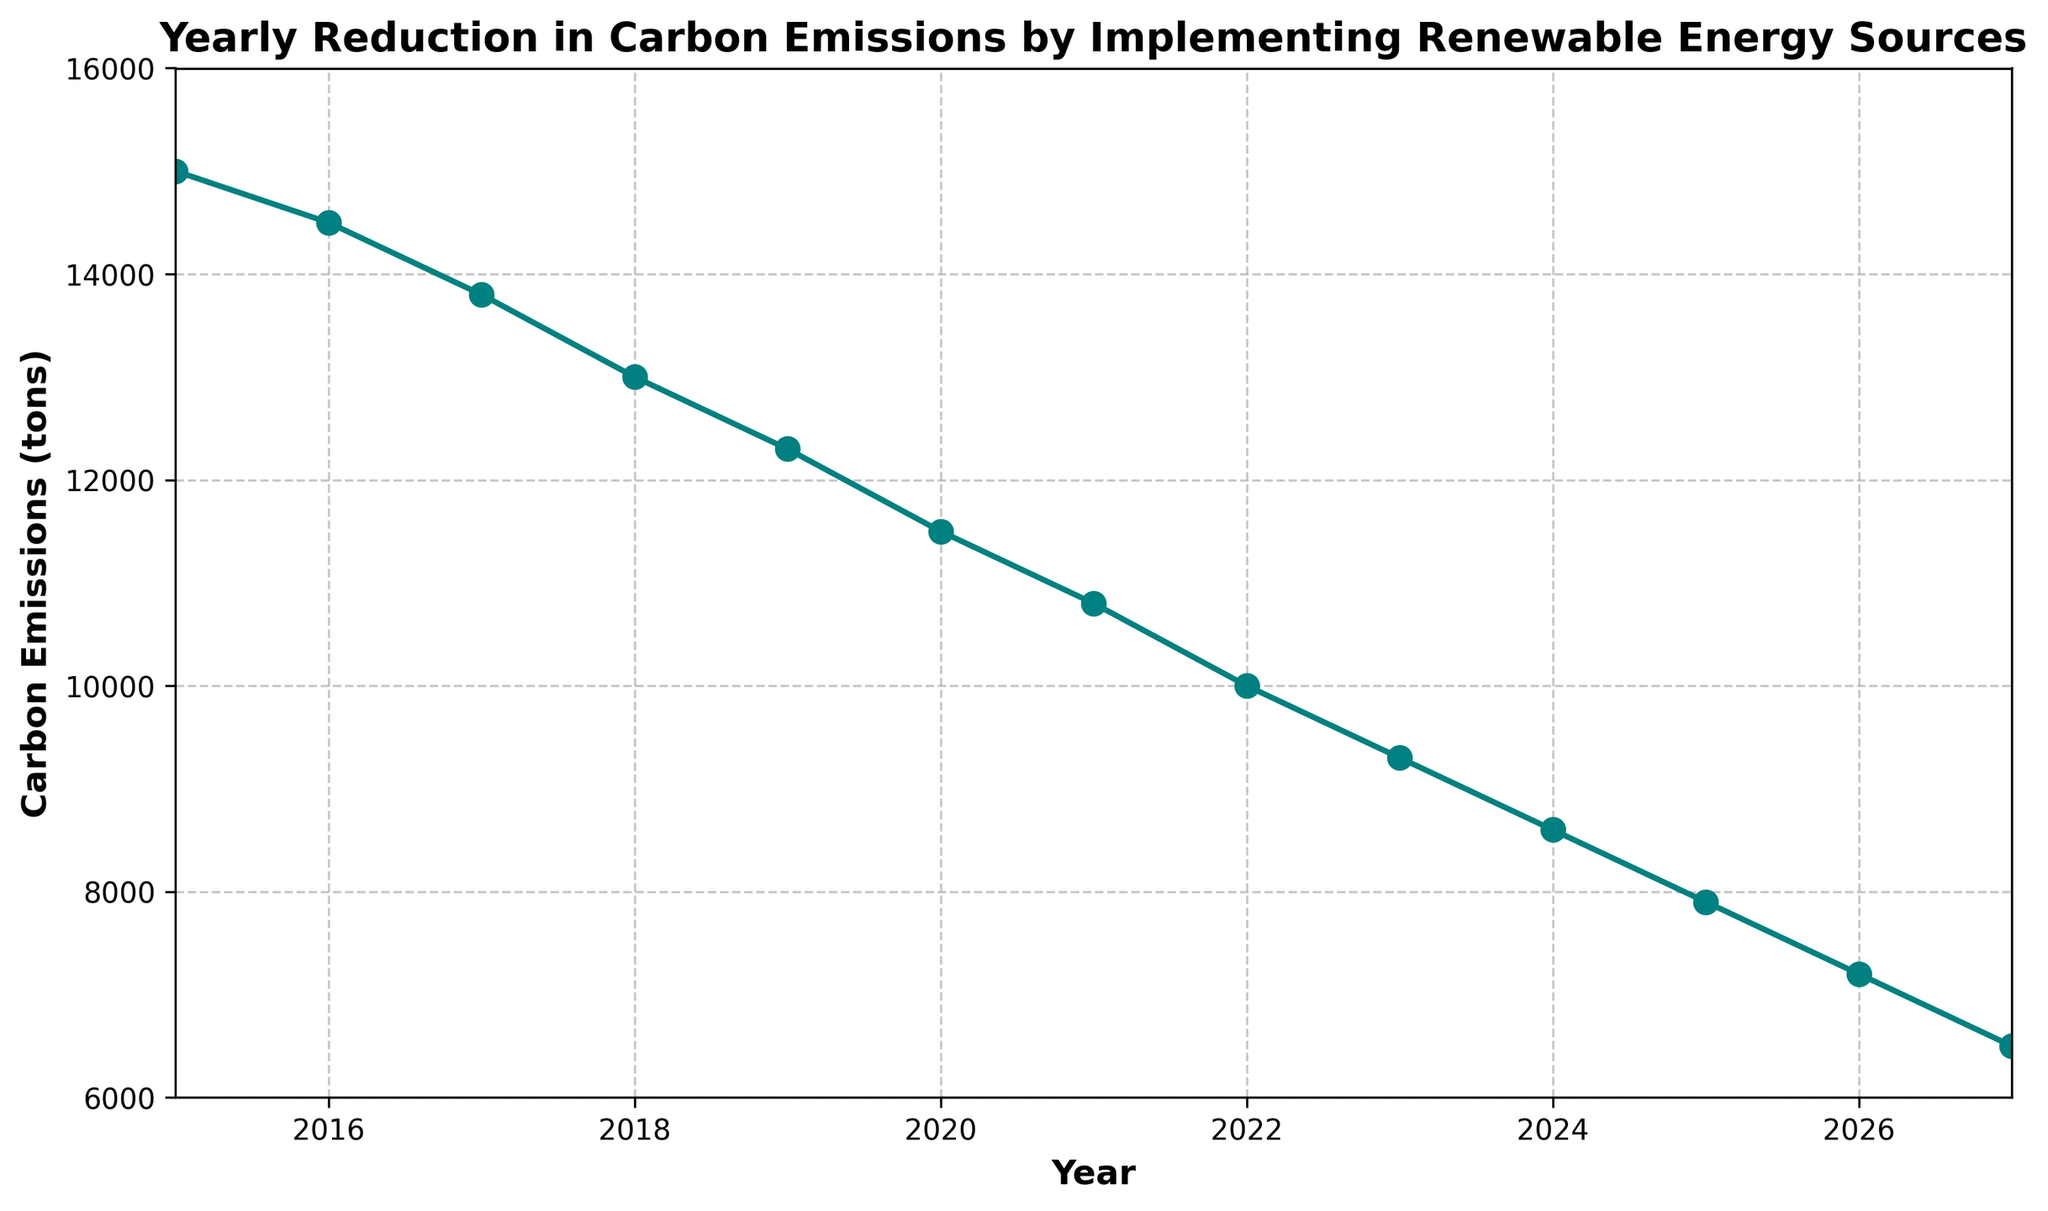what is the trend of carbon emissions from 2015 to 2027? The trend can be observed by looking at the overall direction of the plotted line from 2015 to 2027. The line shows a consistent downward slope, indicating a decrease in carbon emissions over the years
Answer: decreasing How much did carbon emissions decrease from 2015 to 2021? To find the decrease, subtract the carbon emissions in 2021 from carbon emissions in 2015. That is, 15000 (2015) - 10800 (2021)
Answer: 4200 tons Which year had the sharpest decline in carbon emissions compared to the previous year? By visually inspecting the steepness of the drops between successive years, the steepest decline appears between 2017 and 2018. Calculate the difference: 13800 (2017) - 13000 (2018) = 800 tons. Compare it within all consecutive yearly differences to confirm.
Answer: 2017 to 2018 By how much did carbon emissions decrease between the year 2022 and 2025? Carbon emissions in 2022 are 10000 tons, and in 2025, they are 7900 tons. The decrease is 10000 - 7900
Answer: 2100 tons In which year did carbon emissions first drop below 10,000 tons? Locate the point where the carbon emissions for the first time drop below 10,000 tons. Observing the figure, 2022 is the first year when it is below 10,000 tons
Answer: 2022 What is the average annual reduction in carbon emissions between 2015 and 2027? First, find the total reduction between 2015 and 2027, which is 15000 - 6500 = 8500 tons. The period between 2015 and 2027 is 12 years. Then, divide the total reduction by the number of years: 8500 tons / 12 years
Answer: 708.33 tons/year What was the carbon emission level in the year 2024 and how does it compare to 2026? The carbon emission level for 2024 is 8600 tons and for 2026 is 7200 tons. The difference is 8600 - 7200
Answer: 1400 tons less How does the carbon emission level in 2019 compare with that in 2023? Carbon emissions in 2019 are 12300 tons, and in 2023, they are 9300 tons. Compare these two values to find the decrease: 12300 - 9300
Answer: 3000 tons less What is the range of carbon emissions shown in the figure? The range is the difference between the maximum and minimum values of carbon emissions shown in the figure. The maximum value is 15000 tons (2015) and the minimum is 6500 tons (2027). So, 15000 - 6500
Answer: 8500 tons What visual element indicates the consistent decrease in carbon emissions over the years? The consistent downward trajectory of the line plot from left (2015) to right (2027) visually indicates a consistent decrease
Answer: downward sloping line 